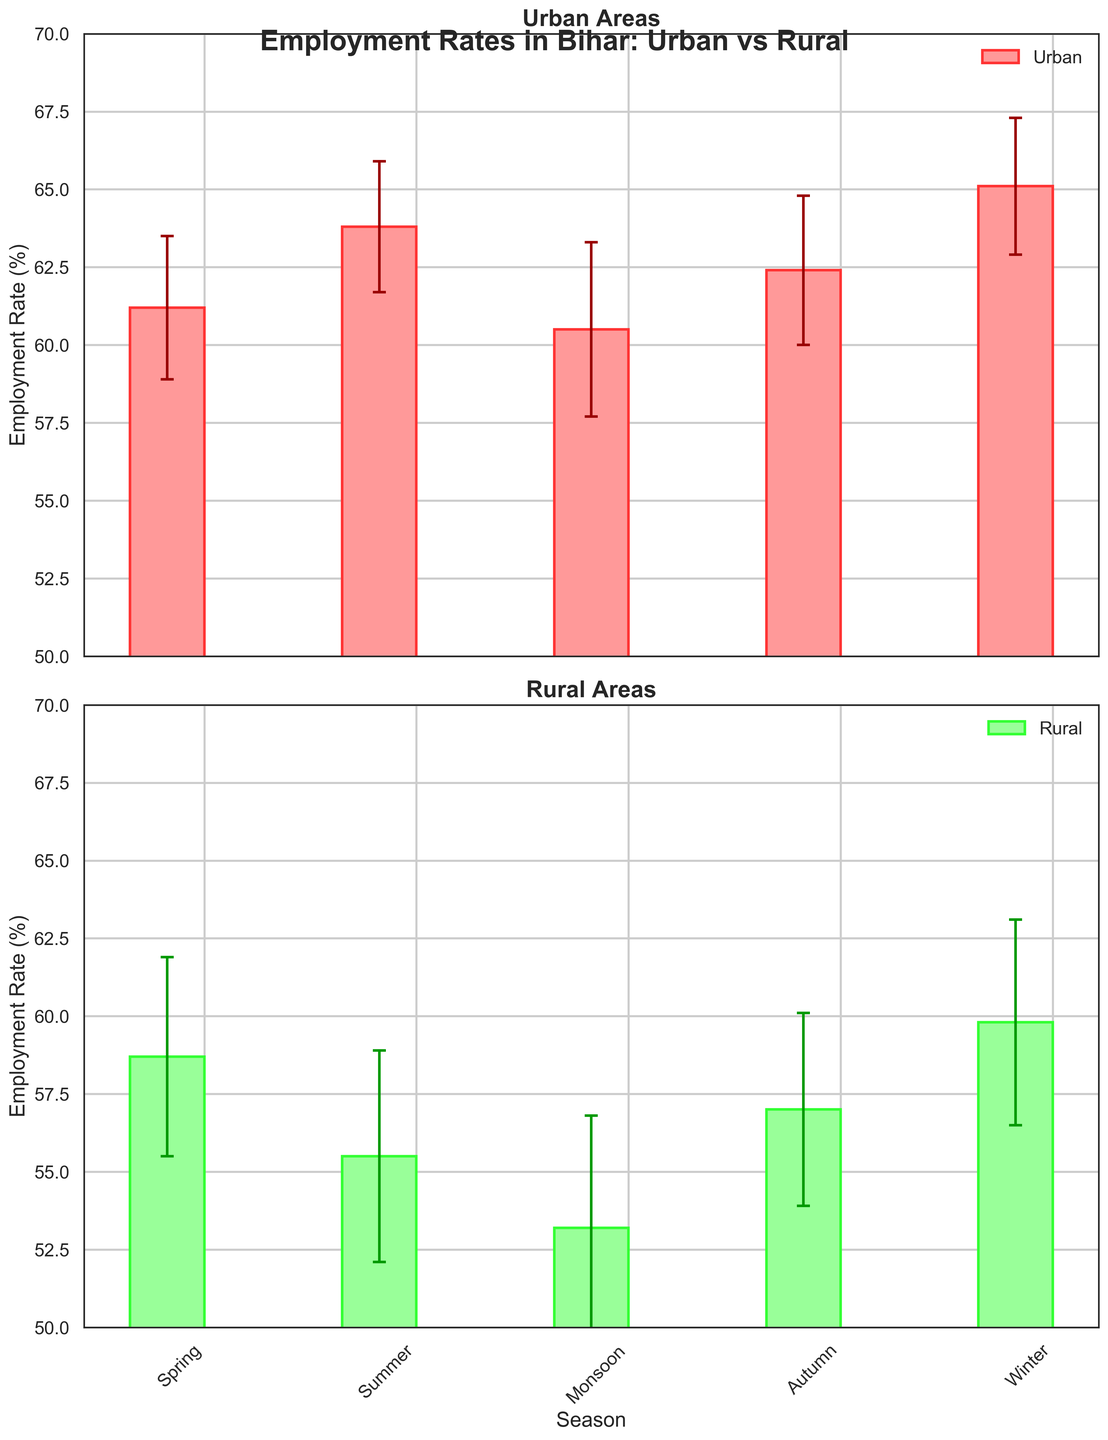what are the titles of the two subplots? The titles of the subplots are the text at the top of each plot. The first subplot is titled "Urban Areas" and the second subplot is titled "Rural Areas."
Answer: Urban Areas and Rural Areas Which area has the highest employment rate in Winter? Looking at the Winter season on the x-axis and comparing the bars, the urban area has a higher employment rate for Winter than the rural area.
Answer: Urban What can you infer from the error bars about the stability of employment rates in urban vs rural areas across seasons? Error bars represent variability. In the plots, urban areas consistently have smaller error bars compared to rural areas, indicating that employment rates in urban areas are more stable and have less variability.
Answer: Urban areas are more stable Which season shows the smallest difference in employment rate between urban and rural areas? To find the smallest difference, subtract the rural rates from the urban rates for each season. For Spring: 61.2 - 58.7 = 2.5, Summer: 63.8 - 55.5 = 8.3, Monsoon: 60.5 - 53.2 = 7.3, Autumn: 62.4 - 57.0 = 5.4, Winter: 65.1 - 59.8 = 5.3. The smallest difference is in the Spring season with a difference of 2.5.
Answer: Spring In which season do rural areas experience the lowest employment rate? By comparing the heights of the bars for rural areas, the lowest employment rate is seen during the Monsoon season.
Answer: Monsoon How does the employment rate trend over the seasons in urban areas? Looking at the urban subplot, the bars rise from Spring to Summer, dip during Monsoon, slightly increase in Autumn, and peak in Winter, indicating fluctuating trends with the highest rate in Winter.
Answer: Fluctuating; peaks in Winter What is the average employment rate for rural areas across all seasons? Add up the employment rates for rural areas and divide by the number of seasons: (58.7 + 55.5 + 53.2 + 57.0 + 59.8) / 5 = 284.2 / 5 = 56.84.
Answer: 56.84 How much higher is the employment rate in urban areas than in rural areas during the Monsoon season? Subtract the employment rate for rural areas from the urban rate for the Monsoon season: 60.5 - 53.2 = 7.3.
Answer: 7.3 Which area, urban or rural, shows a greater rate of increase in employment rates from Spring to Summer? Calculate the increase for each area: Urban: 63.8 - 61.2 = 2.6, Rural: 55.5 - 58.7 = -3.2. The urban area shows an increase, whereas the rural area shows a decrease.
Answer: Urban Is there any season where the employment rates for rural areas fall within the error margin of urban areas? The error margins for urban areas across different seasons do not overlap with rural rates, indicating no rural season falls within the urban area’s error margin.
Answer: No 